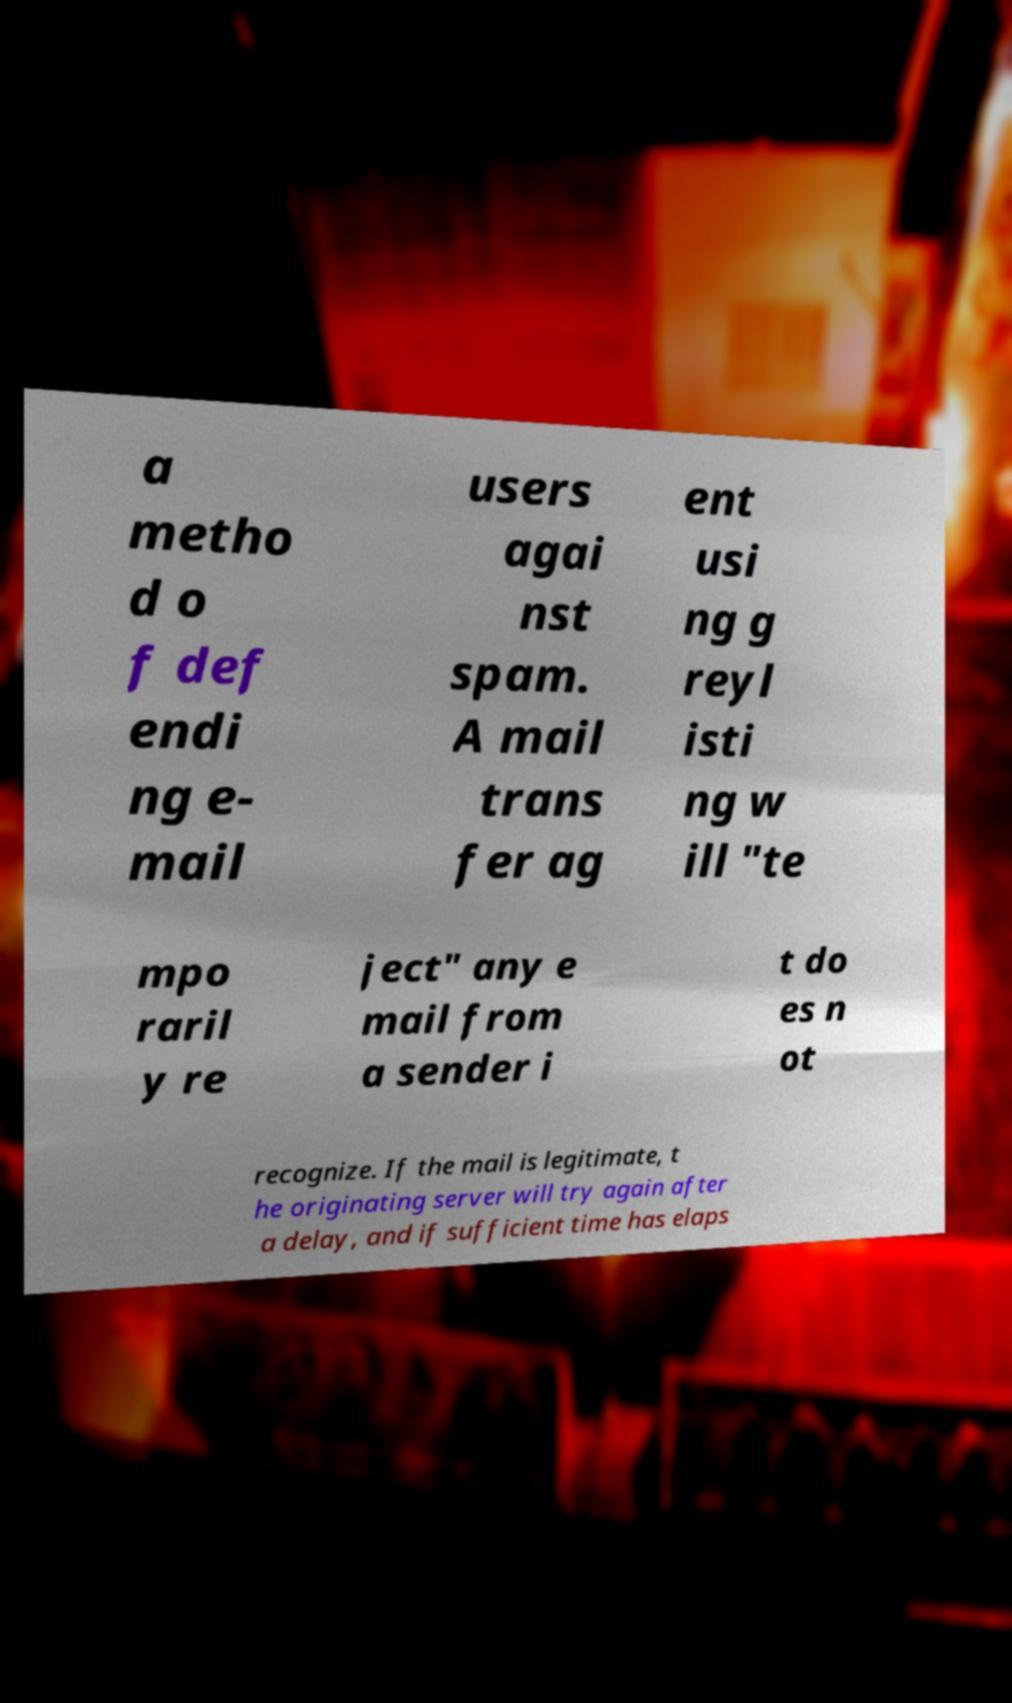Could you extract and type out the text from this image? a metho d o f def endi ng e- mail users agai nst spam. A mail trans fer ag ent usi ng g reyl isti ng w ill "te mpo raril y re ject" any e mail from a sender i t do es n ot recognize. If the mail is legitimate, t he originating server will try again after a delay, and if sufficient time has elaps 